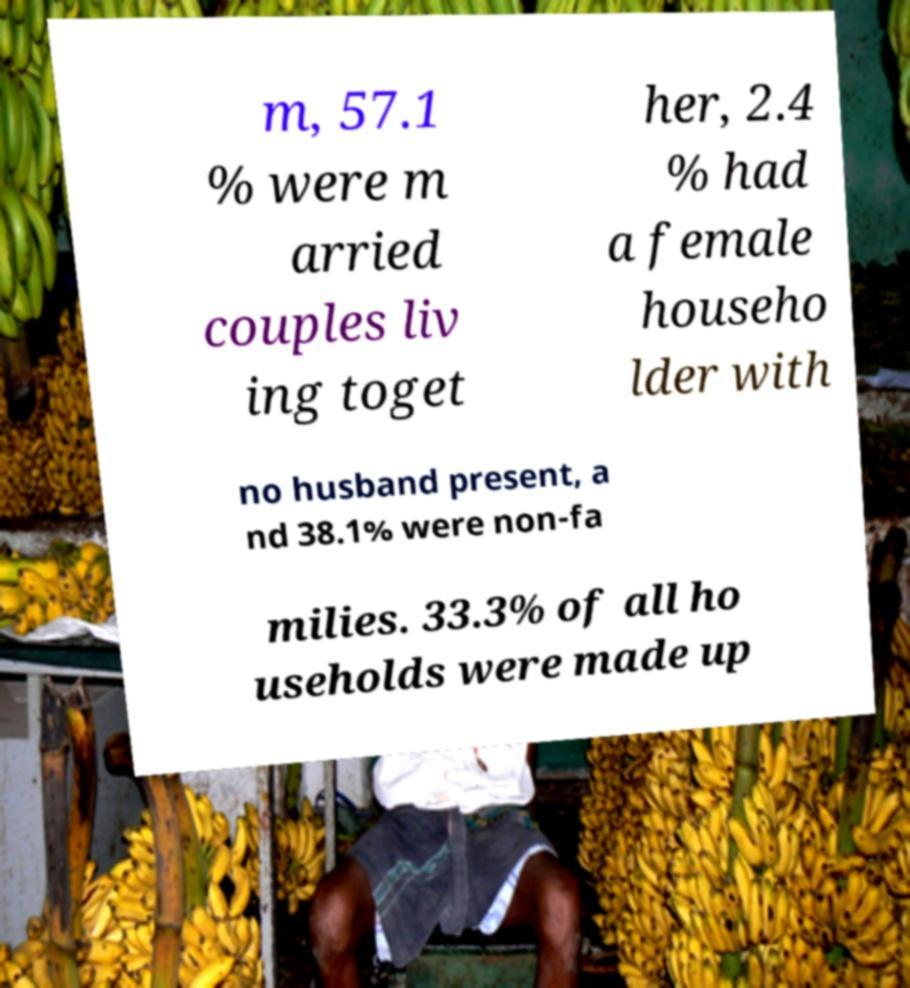Please read and relay the text visible in this image. What does it say? m, 57.1 % were m arried couples liv ing toget her, 2.4 % had a female househo lder with no husband present, a nd 38.1% were non-fa milies. 33.3% of all ho useholds were made up 